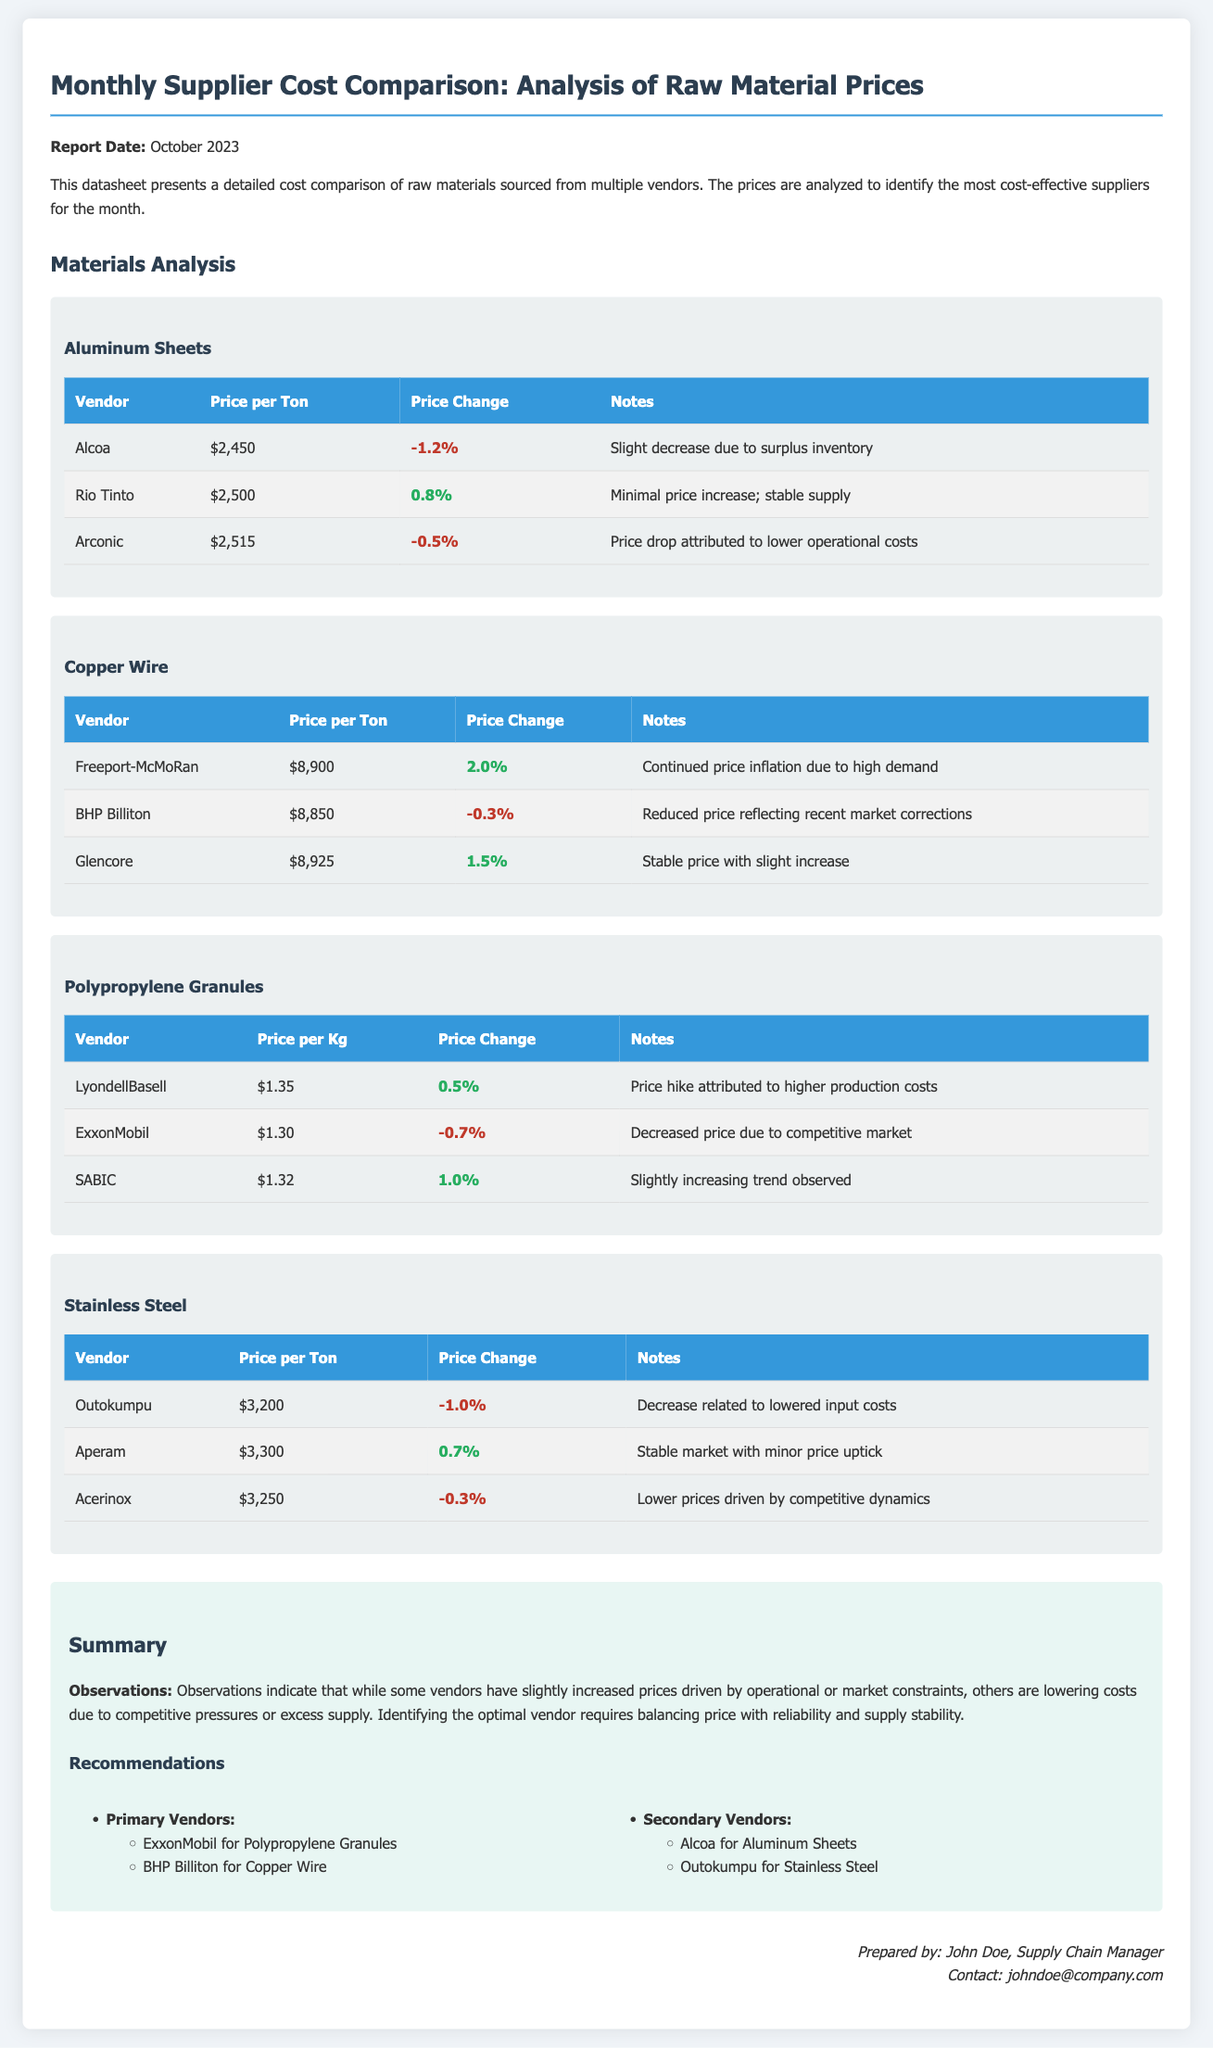what are the prices of Aluminum Sheets from Alcoa? The document lists the price for Aluminum Sheets from Alcoa as $2,450 per ton.
Answer: $2,450 who is the primary vendor for Polypropylene Granules? The recommendations section identifies ExxonMobil as the primary vendor for Polypropylene Granules.
Answer: ExxonMobil what was the price change for Copper Wire from Freeport-McMoRan? The price change for Copper Wire from Freeport-McMoRan is noted as +2.0%.
Answer: +2.0% which vendor has the lowest price for Stainless Steel? The document states that Outokumpu has the lowest price for Stainless Steel at $3,200 per ton.
Answer: Outokumpu what is the price per kg of Polypropylene Granules from ExxonMobil? The price per kg of Polypropylene Granules from ExxonMobil is $1.30.
Answer: $1.30 which raw material has a price decrease from Alcoa? The materials analysis lists Aluminum Sheets as having a price decrease from Alcoa.
Answer: Aluminum Sheets how many vendors were analyzed for Copper Wire? There are three vendors analyzed for Copper Wire in the document.
Answer: Three what is the report date for this datasheet? The report date provided at the top of the document is October 2023.
Answer: October 2023 